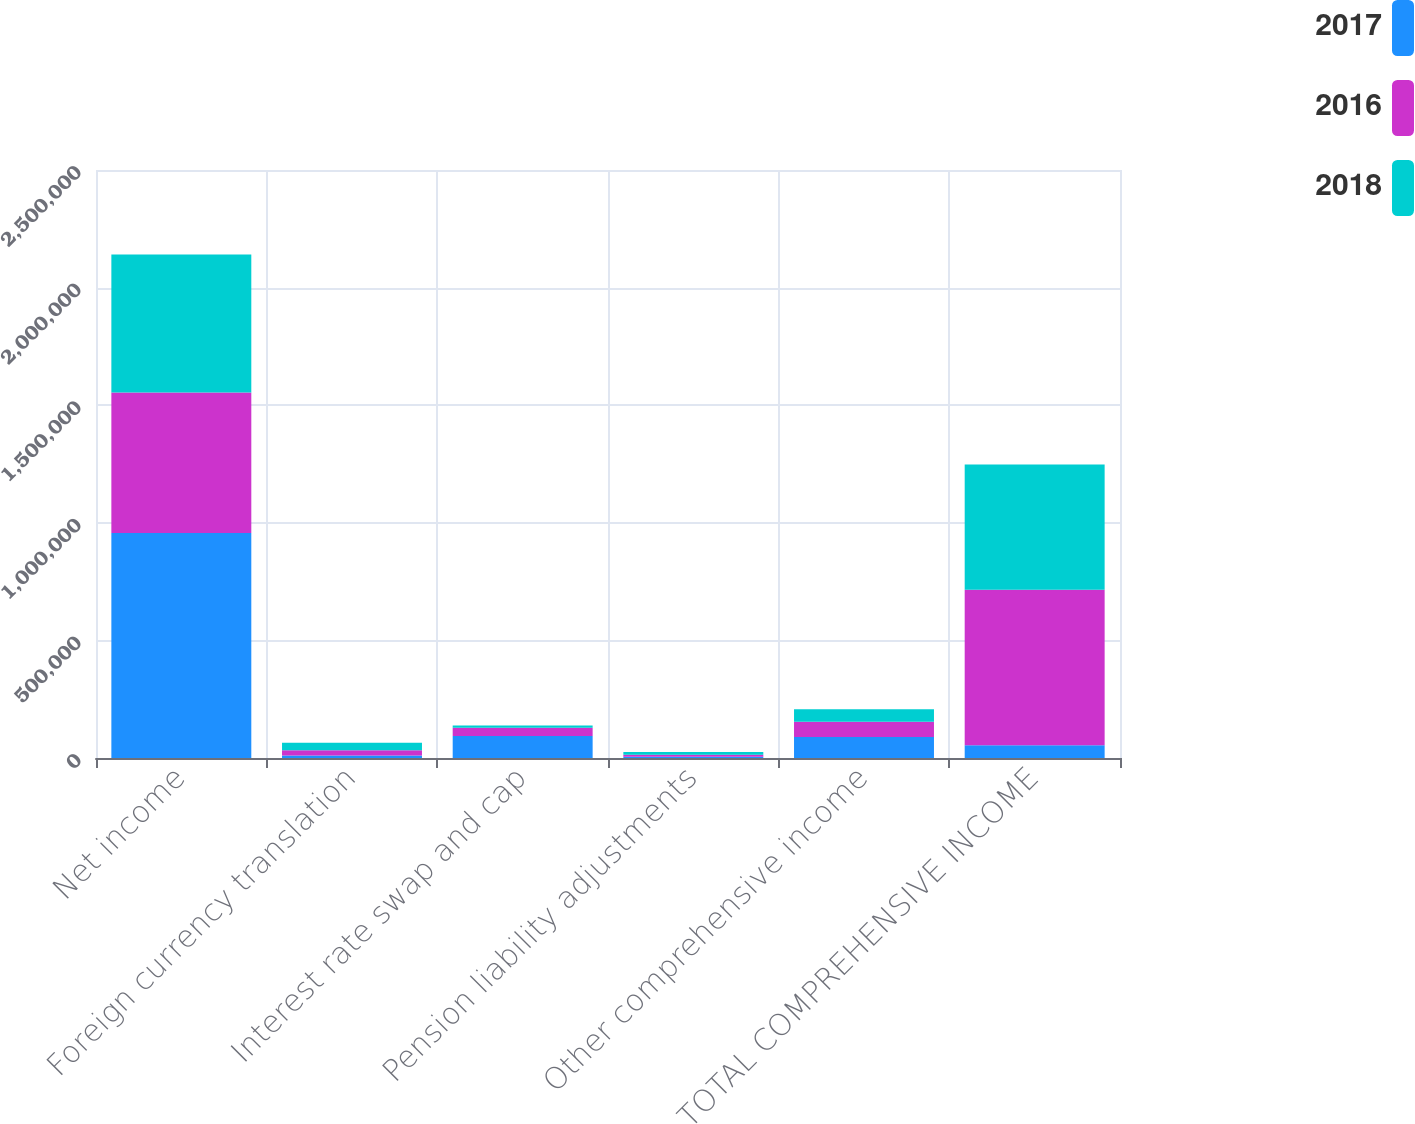Convert chart. <chart><loc_0><loc_0><loc_500><loc_500><stacked_bar_chart><ecel><fcel>Net income<fcel>Foreign currency translation<fcel>Interest rate swap and cap<fcel>Pension liability adjustments<fcel>Other comprehensive income<fcel>TOTAL COMPREHENSIVE INCOME<nl><fcel>2017<fcel>957062<fcel>10253<fcel>93860<fcel>5636<fcel>89243<fcel>53778<nl><fcel>2016<fcel>596887<fcel>22241<fcel>34471<fcel>7932<fcel>64644<fcel>661531<nl><fcel>2018<fcel>586414<fcel>31846<fcel>9648<fcel>12284<fcel>53778<fcel>532636<nl></chart> 